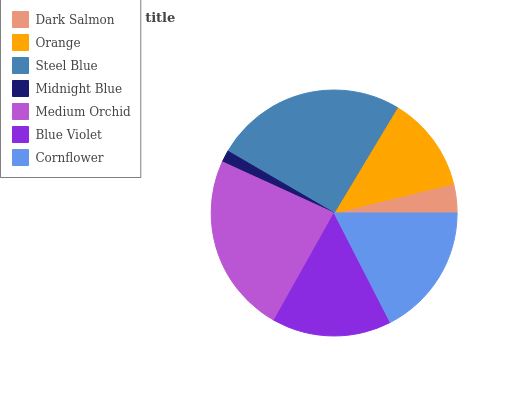Is Midnight Blue the minimum?
Answer yes or no. Yes. Is Steel Blue the maximum?
Answer yes or no. Yes. Is Orange the minimum?
Answer yes or no. No. Is Orange the maximum?
Answer yes or no. No. Is Orange greater than Dark Salmon?
Answer yes or no. Yes. Is Dark Salmon less than Orange?
Answer yes or no. Yes. Is Dark Salmon greater than Orange?
Answer yes or no. No. Is Orange less than Dark Salmon?
Answer yes or no. No. Is Blue Violet the high median?
Answer yes or no. Yes. Is Blue Violet the low median?
Answer yes or no. Yes. Is Orange the high median?
Answer yes or no. No. Is Midnight Blue the low median?
Answer yes or no. No. 